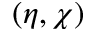<formula> <loc_0><loc_0><loc_500><loc_500>( \eta , \chi )</formula> 